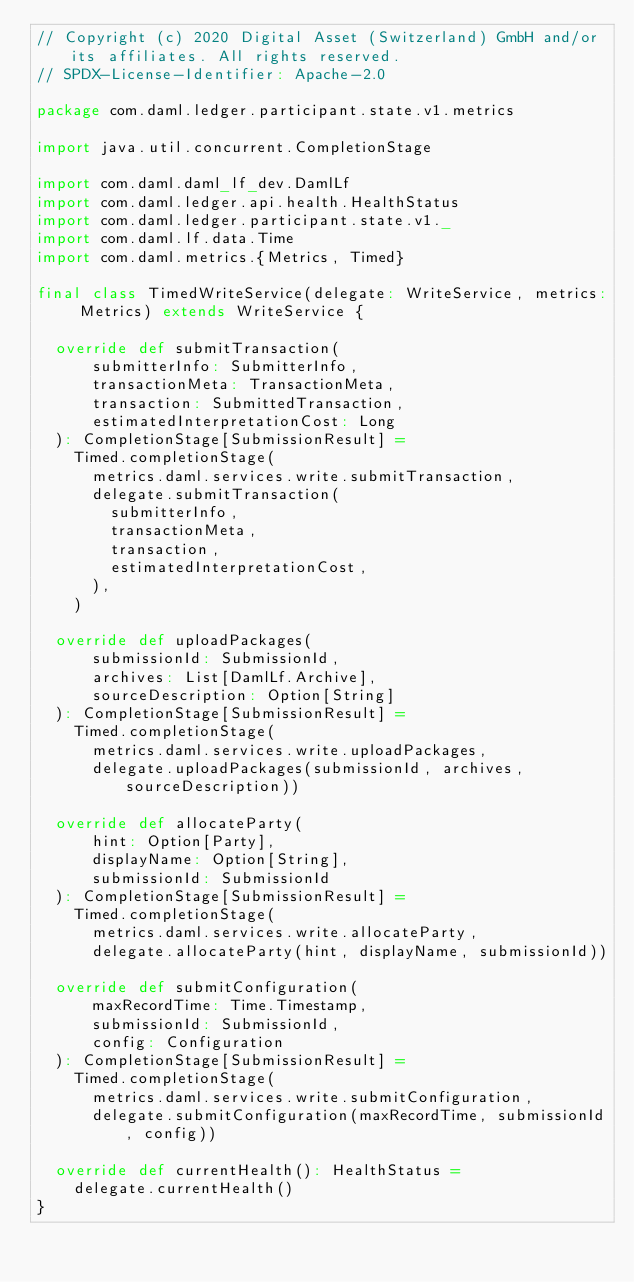Convert code to text. <code><loc_0><loc_0><loc_500><loc_500><_Scala_>// Copyright (c) 2020 Digital Asset (Switzerland) GmbH and/or its affiliates. All rights reserved.
// SPDX-License-Identifier: Apache-2.0

package com.daml.ledger.participant.state.v1.metrics

import java.util.concurrent.CompletionStage

import com.daml.daml_lf_dev.DamlLf
import com.daml.ledger.api.health.HealthStatus
import com.daml.ledger.participant.state.v1._
import com.daml.lf.data.Time
import com.daml.metrics.{Metrics, Timed}

final class TimedWriteService(delegate: WriteService, metrics: Metrics) extends WriteService {

  override def submitTransaction(
      submitterInfo: SubmitterInfo,
      transactionMeta: TransactionMeta,
      transaction: SubmittedTransaction,
      estimatedInterpretationCost: Long
  ): CompletionStage[SubmissionResult] =
    Timed.completionStage(
      metrics.daml.services.write.submitTransaction,
      delegate.submitTransaction(
        submitterInfo,
        transactionMeta,
        transaction,
        estimatedInterpretationCost,
      ),
    )

  override def uploadPackages(
      submissionId: SubmissionId,
      archives: List[DamlLf.Archive],
      sourceDescription: Option[String]
  ): CompletionStage[SubmissionResult] =
    Timed.completionStage(
      metrics.daml.services.write.uploadPackages,
      delegate.uploadPackages(submissionId, archives, sourceDescription))

  override def allocateParty(
      hint: Option[Party],
      displayName: Option[String],
      submissionId: SubmissionId
  ): CompletionStage[SubmissionResult] =
    Timed.completionStage(
      metrics.daml.services.write.allocateParty,
      delegate.allocateParty(hint, displayName, submissionId))

  override def submitConfiguration(
      maxRecordTime: Time.Timestamp,
      submissionId: SubmissionId,
      config: Configuration
  ): CompletionStage[SubmissionResult] =
    Timed.completionStage(
      metrics.daml.services.write.submitConfiguration,
      delegate.submitConfiguration(maxRecordTime, submissionId, config))

  override def currentHealth(): HealthStatus =
    delegate.currentHealth()
}
</code> 